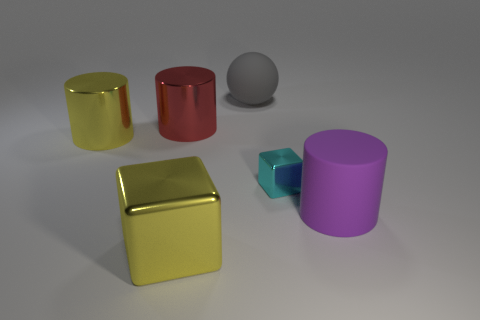Is there any other thing that has the same size as the cyan block?
Your answer should be very brief. No. Does the matte cylinder have the same size as the yellow cylinder?
Give a very brief answer. Yes. How many things are either large matte cylinders or large things that are behind the cyan shiny block?
Your answer should be compact. 4. What material is the sphere that is the same size as the red cylinder?
Your answer should be compact. Rubber. The object that is both in front of the tiny thing and to the right of the sphere is made of what material?
Keep it short and to the point. Rubber. Are there any objects in front of the block on the right side of the gray thing?
Ensure brevity in your answer.  Yes. There is a object that is on the right side of the rubber ball and on the left side of the large purple rubber cylinder; how big is it?
Make the answer very short. Small. What number of purple things are blocks or tiny things?
Provide a succinct answer. 0. There is a gray thing that is the same size as the red metallic cylinder; what is its shape?
Give a very brief answer. Sphere. What number of other objects are there of the same color as the matte ball?
Your response must be concise. 0. 